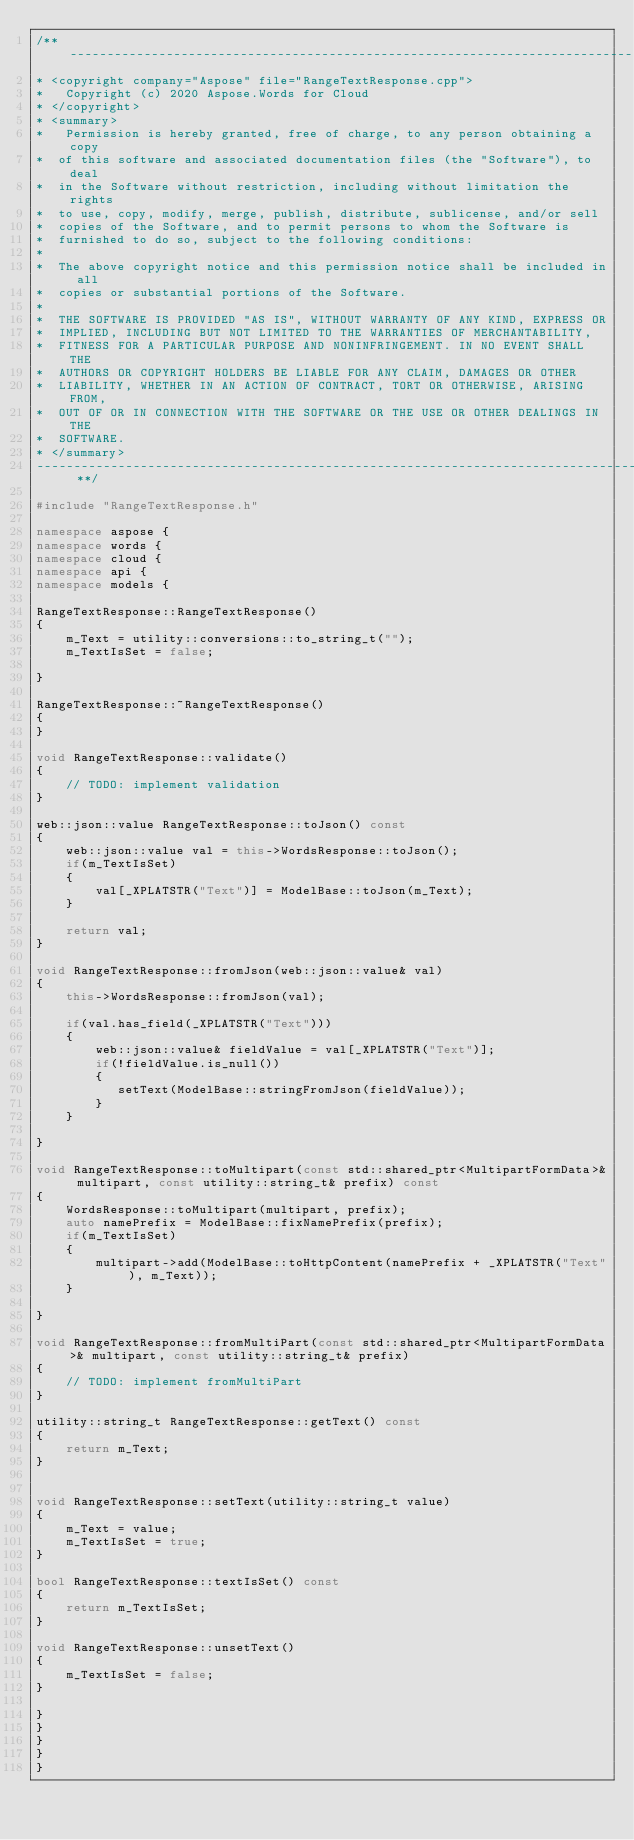Convert code to text. <code><loc_0><loc_0><loc_500><loc_500><_C++_>/** --------------------------------------------------------------------------------------------------------------------
* <copyright company="Aspose" file="RangeTextResponse.cpp">
*   Copyright (c) 2020 Aspose.Words for Cloud
* </copyright>
* <summary>
*   Permission is hereby granted, free of charge, to any person obtaining a copy
*  of this software and associated documentation files (the "Software"), to deal
*  in the Software without restriction, including without limitation the rights
*  to use, copy, modify, merge, publish, distribute, sublicense, and/or sell
*  copies of the Software, and to permit persons to whom the Software is
*  furnished to do so, subject to the following conditions:
* 
*  The above copyright notice and this permission notice shall be included in all
*  copies or substantial portions of the Software.
* 
*  THE SOFTWARE IS PROVIDED "AS IS", WITHOUT WARRANTY OF ANY KIND, EXPRESS OR
*  IMPLIED, INCLUDING BUT NOT LIMITED TO THE WARRANTIES OF MERCHANTABILITY,
*  FITNESS FOR A PARTICULAR PURPOSE AND NONINFRINGEMENT. IN NO EVENT SHALL THE
*  AUTHORS OR COPYRIGHT HOLDERS BE LIABLE FOR ANY CLAIM, DAMAGES OR OTHER
*  LIABILITY, WHETHER IN AN ACTION OF CONTRACT, TORT OR OTHERWISE, ARISING FROM,
*  OUT OF OR IN CONNECTION WITH THE SOFTWARE OR THE USE OR OTHER DEALINGS IN THE
*  SOFTWARE.
* </summary> 
-------------------------------------------------------------------------------------------------------------------- **/

#include "RangeTextResponse.h"

namespace aspose {
namespace words {
namespace cloud {
namespace api {
namespace models {

RangeTextResponse::RangeTextResponse()
{
    m_Text = utility::conversions::to_string_t("");
    m_TextIsSet = false;

}

RangeTextResponse::~RangeTextResponse()
{
}

void RangeTextResponse::validate()
{
    // TODO: implement validation
}

web::json::value RangeTextResponse::toJson() const
{
    web::json::value val = this->WordsResponse::toJson();
    if(m_TextIsSet)
    {
        val[_XPLATSTR("Text")] = ModelBase::toJson(m_Text);
    }

    return val;
}

void RangeTextResponse::fromJson(web::json::value& val)
{
    this->WordsResponse::fromJson(val);

    if(val.has_field(_XPLATSTR("Text")))
    {
        web::json::value& fieldValue = val[_XPLATSTR("Text")];
        if(!fieldValue.is_null())
        {
           setText(ModelBase::stringFromJson(fieldValue));
        }
    }

}

void RangeTextResponse::toMultipart(const std::shared_ptr<MultipartFormData>& multipart, const utility::string_t& prefix) const
{
    WordsResponse::toMultipart(multipart, prefix);
    auto namePrefix = ModelBase::fixNamePrefix(prefix);
    if(m_TextIsSet)
    {
        multipart->add(ModelBase::toHttpContent(namePrefix + _XPLATSTR("Text"), m_Text));
    }

}

void RangeTextResponse::fromMultiPart(const std::shared_ptr<MultipartFormData>& multipart, const utility::string_t& prefix)
{
    // TODO: implement fromMultiPart
}

utility::string_t RangeTextResponse::getText() const
{
    return m_Text;
}


void RangeTextResponse::setText(utility::string_t value)
{
    m_Text = value;
    m_TextIsSet = true;
}

bool RangeTextResponse::textIsSet() const
{
    return m_TextIsSet;
}

void RangeTextResponse::unsetText()
{
    m_TextIsSet = false;
}

}
}
}
}
}
</code> 